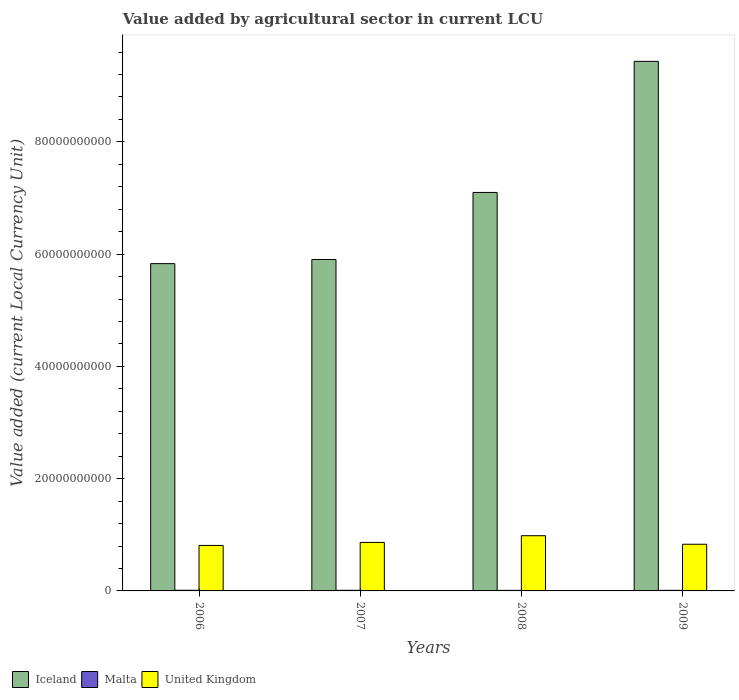Are the number of bars per tick equal to the number of legend labels?
Keep it short and to the point. Yes. Are the number of bars on each tick of the X-axis equal?
Your answer should be very brief. Yes. How many bars are there on the 2nd tick from the right?
Give a very brief answer. 3. What is the label of the 1st group of bars from the left?
Make the answer very short. 2006. In how many cases, is the number of bars for a given year not equal to the number of legend labels?
Your answer should be very brief. 0. What is the value added by agricultural sector in Iceland in 2008?
Offer a very short reply. 7.10e+1. Across all years, what is the maximum value added by agricultural sector in Malta?
Your answer should be very brief. 1.17e+08. Across all years, what is the minimum value added by agricultural sector in Malta?
Offer a terse response. 9.48e+07. What is the total value added by agricultural sector in United Kingdom in the graph?
Your answer should be very brief. 3.49e+1. What is the difference between the value added by agricultural sector in Malta in 2006 and that in 2009?
Offer a very short reply. 1.27e+07. What is the difference between the value added by agricultural sector in United Kingdom in 2008 and the value added by agricultural sector in Malta in 2009?
Offer a very short reply. 9.73e+09. What is the average value added by agricultural sector in Malta per year?
Provide a succinct answer. 1.07e+08. In the year 2007, what is the difference between the value added by agricultural sector in United Kingdom and value added by agricultural sector in Malta?
Offer a terse response. 8.53e+09. In how many years, is the value added by agricultural sector in Malta greater than 64000000000 LCU?
Give a very brief answer. 0. What is the ratio of the value added by agricultural sector in Iceland in 2008 to that in 2009?
Provide a succinct answer. 0.75. Is the value added by agricultural sector in United Kingdom in 2006 less than that in 2007?
Give a very brief answer. Yes. What is the difference between the highest and the second highest value added by agricultural sector in United Kingdom?
Make the answer very short. 1.20e+09. What is the difference between the highest and the lowest value added by agricultural sector in Iceland?
Give a very brief answer. 3.60e+1. Is the sum of the value added by agricultural sector in Iceland in 2006 and 2009 greater than the maximum value added by agricultural sector in Malta across all years?
Your answer should be compact. Yes. What does the 3rd bar from the left in 2007 represents?
Offer a very short reply. United Kingdom. What does the 3rd bar from the right in 2007 represents?
Your response must be concise. Iceland. Is it the case that in every year, the sum of the value added by agricultural sector in Iceland and value added by agricultural sector in United Kingdom is greater than the value added by agricultural sector in Malta?
Your response must be concise. Yes. How many bars are there?
Your response must be concise. 12. Are all the bars in the graph horizontal?
Provide a succinct answer. No. What is the difference between two consecutive major ticks on the Y-axis?
Provide a short and direct response. 2.00e+1. Are the values on the major ticks of Y-axis written in scientific E-notation?
Ensure brevity in your answer.  No. Where does the legend appear in the graph?
Offer a very short reply. Bottom left. What is the title of the graph?
Provide a short and direct response. Value added by agricultural sector in current LCU. What is the label or title of the X-axis?
Provide a short and direct response. Years. What is the label or title of the Y-axis?
Your answer should be compact. Value added (current Local Currency Unit). What is the Value added (current Local Currency Unit) of Iceland in 2006?
Your answer should be compact. 5.83e+1. What is the Value added (current Local Currency Unit) of Malta in 2006?
Make the answer very short. 1.17e+08. What is the Value added (current Local Currency Unit) in United Kingdom in 2006?
Keep it short and to the point. 8.10e+09. What is the Value added (current Local Currency Unit) of Iceland in 2007?
Make the answer very short. 5.90e+1. What is the Value added (current Local Currency Unit) in Malta in 2007?
Keep it short and to the point. 1.13e+08. What is the Value added (current Local Currency Unit) in United Kingdom in 2007?
Ensure brevity in your answer.  8.64e+09. What is the Value added (current Local Currency Unit) in Iceland in 2008?
Your answer should be very brief. 7.10e+1. What is the Value added (current Local Currency Unit) of Malta in 2008?
Offer a very short reply. 9.48e+07. What is the Value added (current Local Currency Unit) in United Kingdom in 2008?
Keep it short and to the point. 9.84e+09. What is the Value added (current Local Currency Unit) of Iceland in 2009?
Ensure brevity in your answer.  9.43e+1. What is the Value added (current Local Currency Unit) in Malta in 2009?
Make the answer very short. 1.04e+08. What is the Value added (current Local Currency Unit) of United Kingdom in 2009?
Give a very brief answer. 8.32e+09. Across all years, what is the maximum Value added (current Local Currency Unit) of Iceland?
Make the answer very short. 9.43e+1. Across all years, what is the maximum Value added (current Local Currency Unit) in Malta?
Provide a succinct answer. 1.17e+08. Across all years, what is the maximum Value added (current Local Currency Unit) in United Kingdom?
Keep it short and to the point. 9.84e+09. Across all years, what is the minimum Value added (current Local Currency Unit) in Iceland?
Provide a succinct answer. 5.83e+1. Across all years, what is the minimum Value added (current Local Currency Unit) of Malta?
Your response must be concise. 9.48e+07. Across all years, what is the minimum Value added (current Local Currency Unit) of United Kingdom?
Your response must be concise. 8.10e+09. What is the total Value added (current Local Currency Unit) in Iceland in the graph?
Offer a very short reply. 2.83e+11. What is the total Value added (current Local Currency Unit) in Malta in the graph?
Your answer should be compact. 4.29e+08. What is the total Value added (current Local Currency Unit) of United Kingdom in the graph?
Your answer should be very brief. 3.49e+1. What is the difference between the Value added (current Local Currency Unit) in Iceland in 2006 and that in 2007?
Ensure brevity in your answer.  -7.37e+08. What is the difference between the Value added (current Local Currency Unit) in United Kingdom in 2006 and that in 2007?
Ensure brevity in your answer.  -5.38e+08. What is the difference between the Value added (current Local Currency Unit) of Iceland in 2006 and that in 2008?
Provide a succinct answer. -1.27e+1. What is the difference between the Value added (current Local Currency Unit) of Malta in 2006 and that in 2008?
Make the answer very short. 2.22e+07. What is the difference between the Value added (current Local Currency Unit) of United Kingdom in 2006 and that in 2008?
Provide a succinct answer. -1.74e+09. What is the difference between the Value added (current Local Currency Unit) of Iceland in 2006 and that in 2009?
Give a very brief answer. -3.60e+1. What is the difference between the Value added (current Local Currency Unit) of Malta in 2006 and that in 2009?
Your response must be concise. 1.27e+07. What is the difference between the Value added (current Local Currency Unit) in United Kingdom in 2006 and that in 2009?
Provide a succinct answer. -2.13e+08. What is the difference between the Value added (current Local Currency Unit) of Iceland in 2007 and that in 2008?
Provide a short and direct response. -1.19e+1. What is the difference between the Value added (current Local Currency Unit) in Malta in 2007 and that in 2008?
Make the answer very short. 1.82e+07. What is the difference between the Value added (current Local Currency Unit) in United Kingdom in 2007 and that in 2008?
Provide a succinct answer. -1.20e+09. What is the difference between the Value added (current Local Currency Unit) of Iceland in 2007 and that in 2009?
Make the answer very short. -3.53e+1. What is the difference between the Value added (current Local Currency Unit) in Malta in 2007 and that in 2009?
Offer a terse response. 8.70e+06. What is the difference between the Value added (current Local Currency Unit) of United Kingdom in 2007 and that in 2009?
Your answer should be compact. 3.25e+08. What is the difference between the Value added (current Local Currency Unit) in Iceland in 2008 and that in 2009?
Ensure brevity in your answer.  -2.34e+1. What is the difference between the Value added (current Local Currency Unit) in Malta in 2008 and that in 2009?
Keep it short and to the point. -9.50e+06. What is the difference between the Value added (current Local Currency Unit) in United Kingdom in 2008 and that in 2009?
Ensure brevity in your answer.  1.52e+09. What is the difference between the Value added (current Local Currency Unit) in Iceland in 2006 and the Value added (current Local Currency Unit) in Malta in 2007?
Your response must be concise. 5.82e+1. What is the difference between the Value added (current Local Currency Unit) of Iceland in 2006 and the Value added (current Local Currency Unit) of United Kingdom in 2007?
Offer a terse response. 4.97e+1. What is the difference between the Value added (current Local Currency Unit) in Malta in 2006 and the Value added (current Local Currency Unit) in United Kingdom in 2007?
Your answer should be compact. -8.52e+09. What is the difference between the Value added (current Local Currency Unit) of Iceland in 2006 and the Value added (current Local Currency Unit) of Malta in 2008?
Provide a succinct answer. 5.82e+1. What is the difference between the Value added (current Local Currency Unit) in Iceland in 2006 and the Value added (current Local Currency Unit) in United Kingdom in 2008?
Give a very brief answer. 4.85e+1. What is the difference between the Value added (current Local Currency Unit) in Malta in 2006 and the Value added (current Local Currency Unit) in United Kingdom in 2008?
Give a very brief answer. -9.72e+09. What is the difference between the Value added (current Local Currency Unit) in Iceland in 2006 and the Value added (current Local Currency Unit) in Malta in 2009?
Your answer should be compact. 5.82e+1. What is the difference between the Value added (current Local Currency Unit) in Iceland in 2006 and the Value added (current Local Currency Unit) in United Kingdom in 2009?
Give a very brief answer. 5.00e+1. What is the difference between the Value added (current Local Currency Unit) of Malta in 2006 and the Value added (current Local Currency Unit) of United Kingdom in 2009?
Ensure brevity in your answer.  -8.20e+09. What is the difference between the Value added (current Local Currency Unit) in Iceland in 2007 and the Value added (current Local Currency Unit) in Malta in 2008?
Your answer should be very brief. 5.89e+1. What is the difference between the Value added (current Local Currency Unit) of Iceland in 2007 and the Value added (current Local Currency Unit) of United Kingdom in 2008?
Offer a terse response. 4.92e+1. What is the difference between the Value added (current Local Currency Unit) in Malta in 2007 and the Value added (current Local Currency Unit) in United Kingdom in 2008?
Provide a short and direct response. -9.72e+09. What is the difference between the Value added (current Local Currency Unit) of Iceland in 2007 and the Value added (current Local Currency Unit) of Malta in 2009?
Provide a short and direct response. 5.89e+1. What is the difference between the Value added (current Local Currency Unit) of Iceland in 2007 and the Value added (current Local Currency Unit) of United Kingdom in 2009?
Your answer should be very brief. 5.07e+1. What is the difference between the Value added (current Local Currency Unit) of Malta in 2007 and the Value added (current Local Currency Unit) of United Kingdom in 2009?
Your answer should be compact. -8.20e+09. What is the difference between the Value added (current Local Currency Unit) of Iceland in 2008 and the Value added (current Local Currency Unit) of Malta in 2009?
Offer a very short reply. 7.09e+1. What is the difference between the Value added (current Local Currency Unit) of Iceland in 2008 and the Value added (current Local Currency Unit) of United Kingdom in 2009?
Your answer should be very brief. 6.27e+1. What is the difference between the Value added (current Local Currency Unit) of Malta in 2008 and the Value added (current Local Currency Unit) of United Kingdom in 2009?
Your response must be concise. -8.22e+09. What is the average Value added (current Local Currency Unit) of Iceland per year?
Provide a succinct answer. 7.07e+1. What is the average Value added (current Local Currency Unit) of Malta per year?
Offer a very short reply. 1.07e+08. What is the average Value added (current Local Currency Unit) in United Kingdom per year?
Give a very brief answer. 8.72e+09. In the year 2006, what is the difference between the Value added (current Local Currency Unit) in Iceland and Value added (current Local Currency Unit) in Malta?
Provide a short and direct response. 5.82e+1. In the year 2006, what is the difference between the Value added (current Local Currency Unit) of Iceland and Value added (current Local Currency Unit) of United Kingdom?
Provide a succinct answer. 5.02e+1. In the year 2006, what is the difference between the Value added (current Local Currency Unit) in Malta and Value added (current Local Currency Unit) in United Kingdom?
Make the answer very short. -7.98e+09. In the year 2007, what is the difference between the Value added (current Local Currency Unit) of Iceland and Value added (current Local Currency Unit) of Malta?
Offer a very short reply. 5.89e+1. In the year 2007, what is the difference between the Value added (current Local Currency Unit) of Iceland and Value added (current Local Currency Unit) of United Kingdom?
Offer a very short reply. 5.04e+1. In the year 2007, what is the difference between the Value added (current Local Currency Unit) in Malta and Value added (current Local Currency Unit) in United Kingdom?
Offer a terse response. -8.53e+09. In the year 2008, what is the difference between the Value added (current Local Currency Unit) in Iceland and Value added (current Local Currency Unit) in Malta?
Your response must be concise. 7.09e+1. In the year 2008, what is the difference between the Value added (current Local Currency Unit) of Iceland and Value added (current Local Currency Unit) of United Kingdom?
Your answer should be very brief. 6.12e+1. In the year 2008, what is the difference between the Value added (current Local Currency Unit) of Malta and Value added (current Local Currency Unit) of United Kingdom?
Provide a short and direct response. -9.74e+09. In the year 2009, what is the difference between the Value added (current Local Currency Unit) of Iceland and Value added (current Local Currency Unit) of Malta?
Make the answer very short. 9.42e+1. In the year 2009, what is the difference between the Value added (current Local Currency Unit) in Iceland and Value added (current Local Currency Unit) in United Kingdom?
Your answer should be compact. 8.60e+1. In the year 2009, what is the difference between the Value added (current Local Currency Unit) in Malta and Value added (current Local Currency Unit) in United Kingdom?
Offer a terse response. -8.21e+09. What is the ratio of the Value added (current Local Currency Unit) of Iceland in 2006 to that in 2007?
Make the answer very short. 0.99. What is the ratio of the Value added (current Local Currency Unit) of Malta in 2006 to that in 2007?
Your response must be concise. 1.04. What is the ratio of the Value added (current Local Currency Unit) in United Kingdom in 2006 to that in 2007?
Your answer should be very brief. 0.94. What is the ratio of the Value added (current Local Currency Unit) of Iceland in 2006 to that in 2008?
Keep it short and to the point. 0.82. What is the ratio of the Value added (current Local Currency Unit) of Malta in 2006 to that in 2008?
Keep it short and to the point. 1.23. What is the ratio of the Value added (current Local Currency Unit) of United Kingdom in 2006 to that in 2008?
Give a very brief answer. 0.82. What is the ratio of the Value added (current Local Currency Unit) in Iceland in 2006 to that in 2009?
Provide a short and direct response. 0.62. What is the ratio of the Value added (current Local Currency Unit) of Malta in 2006 to that in 2009?
Give a very brief answer. 1.12. What is the ratio of the Value added (current Local Currency Unit) in United Kingdom in 2006 to that in 2009?
Offer a very short reply. 0.97. What is the ratio of the Value added (current Local Currency Unit) of Iceland in 2007 to that in 2008?
Offer a terse response. 0.83. What is the ratio of the Value added (current Local Currency Unit) in Malta in 2007 to that in 2008?
Offer a very short reply. 1.19. What is the ratio of the Value added (current Local Currency Unit) in United Kingdom in 2007 to that in 2008?
Make the answer very short. 0.88. What is the ratio of the Value added (current Local Currency Unit) in Iceland in 2007 to that in 2009?
Your answer should be compact. 0.63. What is the ratio of the Value added (current Local Currency Unit) of Malta in 2007 to that in 2009?
Offer a very short reply. 1.08. What is the ratio of the Value added (current Local Currency Unit) in United Kingdom in 2007 to that in 2009?
Offer a terse response. 1.04. What is the ratio of the Value added (current Local Currency Unit) in Iceland in 2008 to that in 2009?
Give a very brief answer. 0.75. What is the ratio of the Value added (current Local Currency Unit) in Malta in 2008 to that in 2009?
Give a very brief answer. 0.91. What is the ratio of the Value added (current Local Currency Unit) of United Kingdom in 2008 to that in 2009?
Your response must be concise. 1.18. What is the difference between the highest and the second highest Value added (current Local Currency Unit) of Iceland?
Provide a short and direct response. 2.34e+1. What is the difference between the highest and the second highest Value added (current Local Currency Unit) in Malta?
Give a very brief answer. 4.00e+06. What is the difference between the highest and the second highest Value added (current Local Currency Unit) in United Kingdom?
Your response must be concise. 1.20e+09. What is the difference between the highest and the lowest Value added (current Local Currency Unit) of Iceland?
Offer a terse response. 3.60e+1. What is the difference between the highest and the lowest Value added (current Local Currency Unit) in Malta?
Your answer should be very brief. 2.22e+07. What is the difference between the highest and the lowest Value added (current Local Currency Unit) in United Kingdom?
Offer a very short reply. 1.74e+09. 